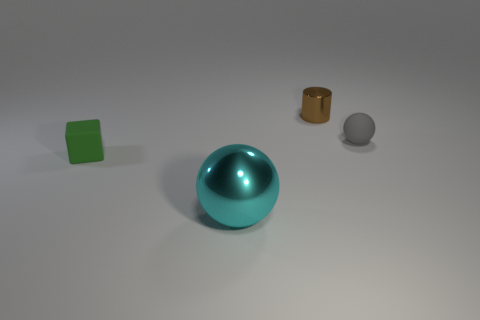Are the tiny object that is on the left side of the tiny cylinder and the sphere left of the brown cylinder made of the same material?
Give a very brief answer. No. There is a sphere that is right of the big thing; what is its material?
Provide a short and direct response. Rubber. How many metal objects are gray spheres or large balls?
Give a very brief answer. 1. There is a small rubber object that is behind the matte object left of the small cylinder; what is its color?
Your answer should be compact. Gray. Is the brown cylinder made of the same material as the small thing that is in front of the gray sphere?
Your answer should be very brief. No. What color is the metal thing that is to the left of the shiny object that is behind the cyan sphere that is in front of the tiny green cube?
Your answer should be very brief. Cyan. Are there any other things that are the same shape as the small shiny object?
Provide a short and direct response. No. Is the number of small brown cylinders greater than the number of objects?
Ensure brevity in your answer.  No. How many small things are in front of the gray rubber sphere and behind the small gray thing?
Offer a very short reply. 0. What number of brown objects are to the left of the tiny thing that is in front of the small gray ball?
Ensure brevity in your answer.  0. 